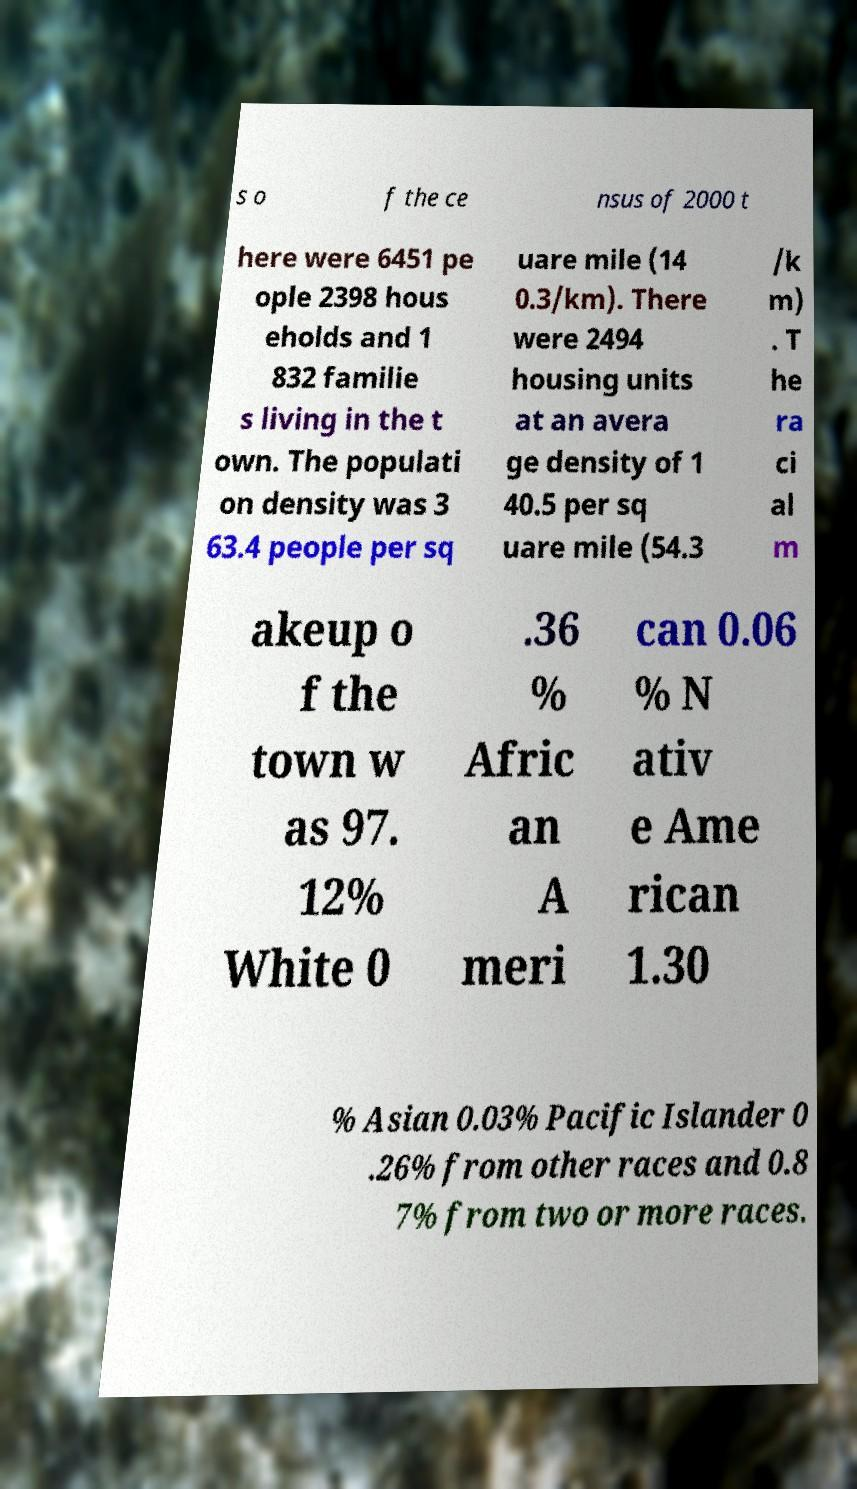Please read and relay the text visible in this image. What does it say? s o f the ce nsus of 2000 t here were 6451 pe ople 2398 hous eholds and 1 832 familie s living in the t own. The populati on density was 3 63.4 people per sq uare mile (14 0.3/km). There were 2494 housing units at an avera ge density of 1 40.5 per sq uare mile (54.3 /k m) . T he ra ci al m akeup o f the town w as 97. 12% White 0 .36 % Afric an A meri can 0.06 % N ativ e Ame rican 1.30 % Asian 0.03% Pacific Islander 0 .26% from other races and 0.8 7% from two or more races. 